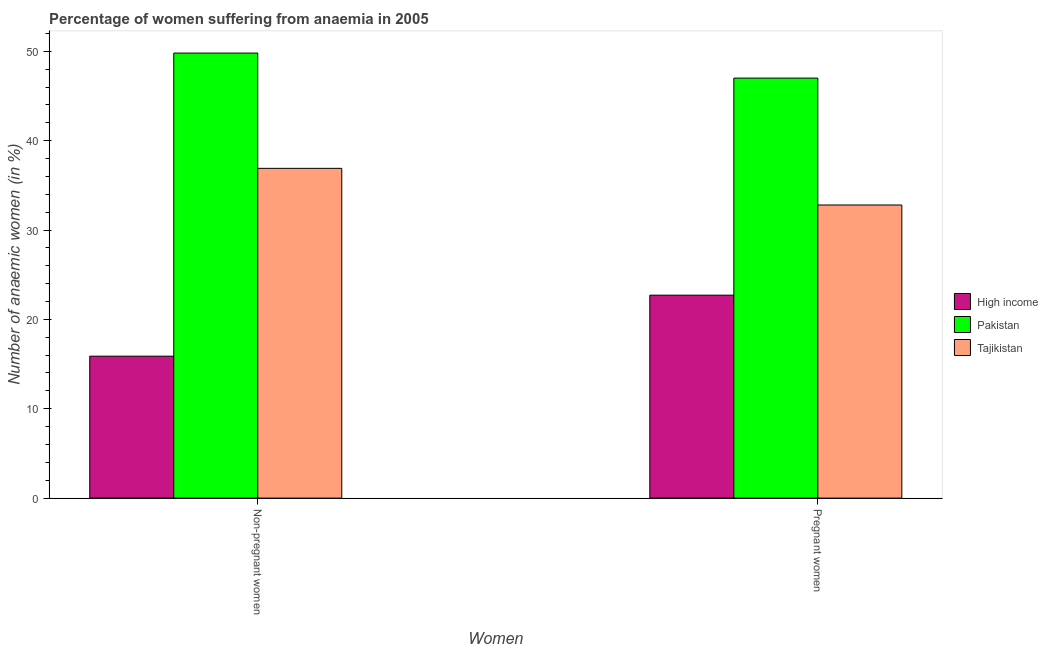How many different coloured bars are there?
Make the answer very short. 3. How many groups of bars are there?
Give a very brief answer. 2. Are the number of bars per tick equal to the number of legend labels?
Make the answer very short. Yes. What is the label of the 1st group of bars from the left?
Your response must be concise. Non-pregnant women. What is the percentage of non-pregnant anaemic women in High income?
Offer a very short reply. 15.88. Across all countries, what is the maximum percentage of non-pregnant anaemic women?
Your answer should be very brief. 49.8. Across all countries, what is the minimum percentage of non-pregnant anaemic women?
Ensure brevity in your answer.  15.88. What is the total percentage of pregnant anaemic women in the graph?
Your answer should be very brief. 102.51. What is the difference between the percentage of non-pregnant anaemic women in Tajikistan and that in Pakistan?
Your answer should be very brief. -12.9. What is the difference between the percentage of pregnant anaemic women in High income and the percentage of non-pregnant anaemic women in Pakistan?
Keep it short and to the point. -27.09. What is the average percentage of pregnant anaemic women per country?
Keep it short and to the point. 34.17. What is the difference between the percentage of pregnant anaemic women and percentage of non-pregnant anaemic women in Tajikistan?
Ensure brevity in your answer.  -4.1. What is the ratio of the percentage of non-pregnant anaemic women in Tajikistan to that in Pakistan?
Keep it short and to the point. 0.74. In how many countries, is the percentage of non-pregnant anaemic women greater than the average percentage of non-pregnant anaemic women taken over all countries?
Provide a succinct answer. 2. What does the 1st bar from the left in Pregnant women represents?
Your answer should be very brief. High income. What does the 2nd bar from the right in Pregnant women represents?
Your answer should be very brief. Pakistan. How many bars are there?
Give a very brief answer. 6. Where does the legend appear in the graph?
Give a very brief answer. Center right. How are the legend labels stacked?
Your answer should be compact. Vertical. What is the title of the graph?
Ensure brevity in your answer.  Percentage of women suffering from anaemia in 2005. Does "Korea (Democratic)" appear as one of the legend labels in the graph?
Your response must be concise. No. What is the label or title of the X-axis?
Your answer should be very brief. Women. What is the label or title of the Y-axis?
Give a very brief answer. Number of anaemic women (in %). What is the Number of anaemic women (in %) in High income in Non-pregnant women?
Give a very brief answer. 15.88. What is the Number of anaemic women (in %) in Pakistan in Non-pregnant women?
Provide a short and direct response. 49.8. What is the Number of anaemic women (in %) in Tajikistan in Non-pregnant women?
Give a very brief answer. 36.9. What is the Number of anaemic women (in %) of High income in Pregnant women?
Ensure brevity in your answer.  22.71. What is the Number of anaemic women (in %) in Pakistan in Pregnant women?
Provide a short and direct response. 47. What is the Number of anaemic women (in %) in Tajikistan in Pregnant women?
Give a very brief answer. 32.8. Across all Women, what is the maximum Number of anaemic women (in %) in High income?
Offer a very short reply. 22.71. Across all Women, what is the maximum Number of anaemic women (in %) of Pakistan?
Give a very brief answer. 49.8. Across all Women, what is the maximum Number of anaemic women (in %) in Tajikistan?
Offer a very short reply. 36.9. Across all Women, what is the minimum Number of anaemic women (in %) in High income?
Your answer should be very brief. 15.88. Across all Women, what is the minimum Number of anaemic women (in %) of Tajikistan?
Your answer should be very brief. 32.8. What is the total Number of anaemic women (in %) in High income in the graph?
Provide a succinct answer. 38.59. What is the total Number of anaemic women (in %) in Pakistan in the graph?
Make the answer very short. 96.8. What is the total Number of anaemic women (in %) of Tajikistan in the graph?
Your answer should be very brief. 69.7. What is the difference between the Number of anaemic women (in %) in High income in Non-pregnant women and that in Pregnant women?
Keep it short and to the point. -6.83. What is the difference between the Number of anaemic women (in %) of Pakistan in Non-pregnant women and that in Pregnant women?
Your answer should be very brief. 2.8. What is the difference between the Number of anaemic women (in %) in Tajikistan in Non-pregnant women and that in Pregnant women?
Offer a very short reply. 4.1. What is the difference between the Number of anaemic women (in %) of High income in Non-pregnant women and the Number of anaemic women (in %) of Pakistan in Pregnant women?
Make the answer very short. -31.12. What is the difference between the Number of anaemic women (in %) in High income in Non-pregnant women and the Number of anaemic women (in %) in Tajikistan in Pregnant women?
Ensure brevity in your answer.  -16.92. What is the difference between the Number of anaemic women (in %) in Pakistan in Non-pregnant women and the Number of anaemic women (in %) in Tajikistan in Pregnant women?
Offer a very short reply. 17. What is the average Number of anaemic women (in %) in High income per Women?
Offer a terse response. 19.3. What is the average Number of anaemic women (in %) in Pakistan per Women?
Keep it short and to the point. 48.4. What is the average Number of anaemic women (in %) of Tajikistan per Women?
Your answer should be very brief. 34.85. What is the difference between the Number of anaemic women (in %) of High income and Number of anaemic women (in %) of Pakistan in Non-pregnant women?
Give a very brief answer. -33.92. What is the difference between the Number of anaemic women (in %) in High income and Number of anaemic women (in %) in Tajikistan in Non-pregnant women?
Your answer should be very brief. -21.02. What is the difference between the Number of anaemic women (in %) of Pakistan and Number of anaemic women (in %) of Tajikistan in Non-pregnant women?
Your response must be concise. 12.9. What is the difference between the Number of anaemic women (in %) of High income and Number of anaemic women (in %) of Pakistan in Pregnant women?
Offer a terse response. -24.29. What is the difference between the Number of anaemic women (in %) in High income and Number of anaemic women (in %) in Tajikistan in Pregnant women?
Ensure brevity in your answer.  -10.09. What is the difference between the Number of anaemic women (in %) in Pakistan and Number of anaemic women (in %) in Tajikistan in Pregnant women?
Ensure brevity in your answer.  14.2. What is the ratio of the Number of anaemic women (in %) of High income in Non-pregnant women to that in Pregnant women?
Keep it short and to the point. 0.7. What is the ratio of the Number of anaemic women (in %) in Pakistan in Non-pregnant women to that in Pregnant women?
Keep it short and to the point. 1.06. What is the difference between the highest and the second highest Number of anaemic women (in %) in High income?
Provide a succinct answer. 6.83. What is the difference between the highest and the lowest Number of anaemic women (in %) in High income?
Offer a very short reply. 6.83. What is the difference between the highest and the lowest Number of anaemic women (in %) in Pakistan?
Provide a short and direct response. 2.8. 